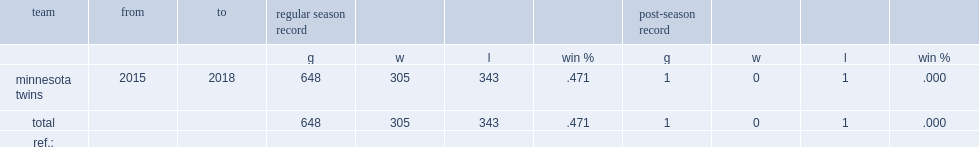How many games did paul molitor play for minnesota twins? 648.0. 